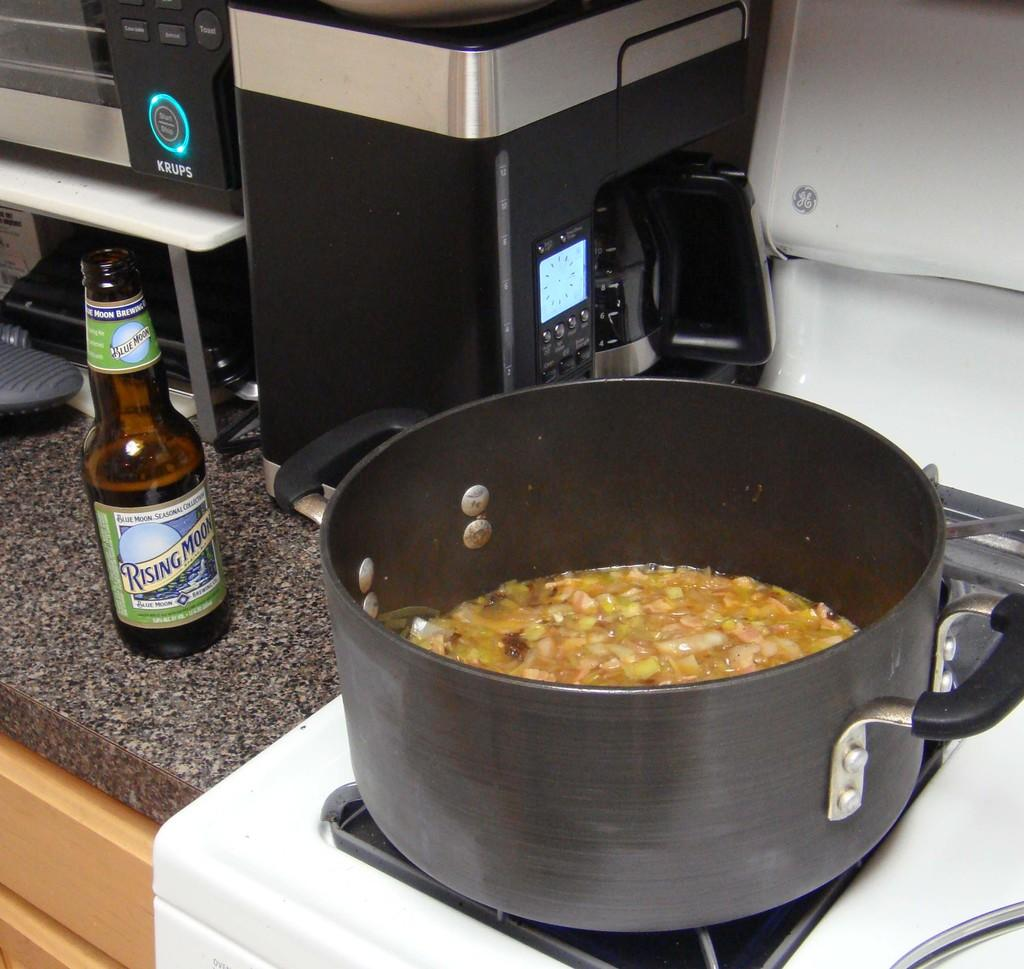<image>
Offer a succinct explanation of the picture presented. A bottle of Rising Moon sits on a counter next to a pot of soup. 